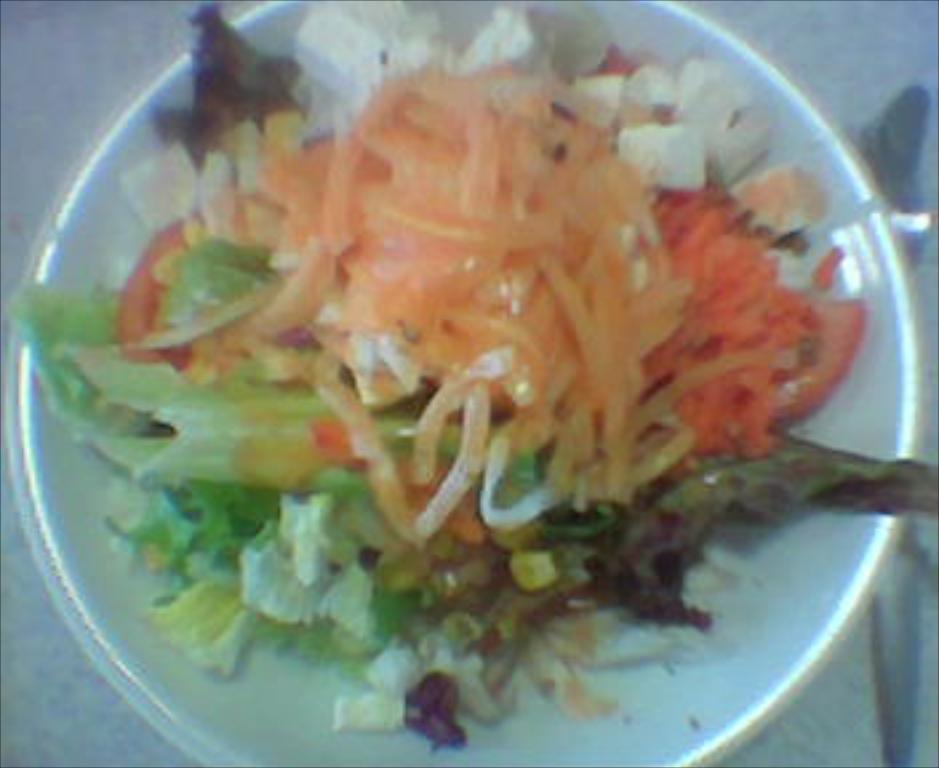What is in the bowl that is visible in the image? There is a food item in the bowl in the image. Where is the bowl located in the image? The bowl is placed on a surface in the image. What type of drum can be seen in the image? There is no drum present in the image; it only features a bowl with a food item on a surface. 